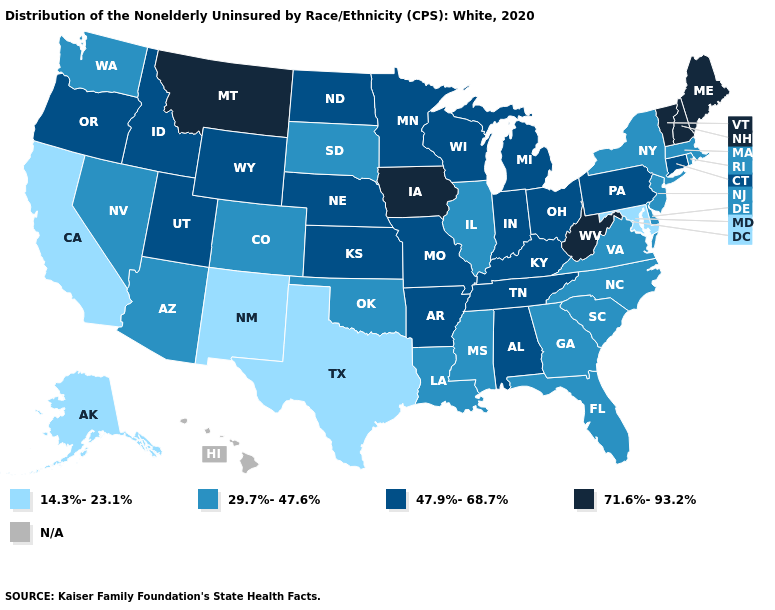What is the lowest value in the West?
Give a very brief answer. 14.3%-23.1%. What is the highest value in the Northeast ?
Keep it brief. 71.6%-93.2%. Which states have the highest value in the USA?
Write a very short answer. Iowa, Maine, Montana, New Hampshire, Vermont, West Virginia. Does West Virginia have the highest value in the South?
Keep it brief. Yes. Does Maryland have the lowest value in the USA?
Be succinct. Yes. Is the legend a continuous bar?
Give a very brief answer. No. What is the value of Oregon?
Answer briefly. 47.9%-68.7%. What is the lowest value in the USA?
Keep it brief. 14.3%-23.1%. Does Texas have the lowest value in the USA?
Give a very brief answer. Yes. Name the states that have a value in the range N/A?
Answer briefly. Hawaii. Does Virginia have the lowest value in the South?
Write a very short answer. No. Does Maryland have the highest value in the South?
Concise answer only. No. Name the states that have a value in the range 14.3%-23.1%?
Keep it brief. Alaska, California, Maryland, New Mexico, Texas. Name the states that have a value in the range 71.6%-93.2%?
Answer briefly. Iowa, Maine, Montana, New Hampshire, Vermont, West Virginia. 